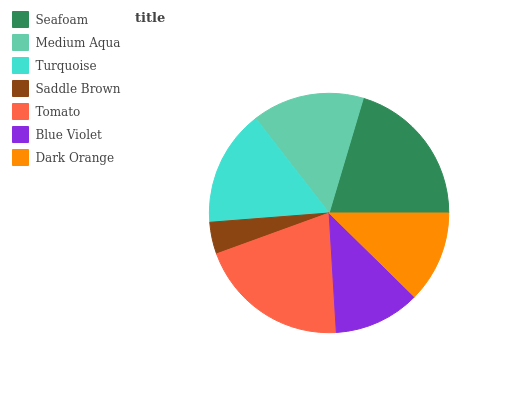Is Saddle Brown the minimum?
Answer yes or no. Yes. Is Tomato the maximum?
Answer yes or no. Yes. Is Medium Aqua the minimum?
Answer yes or no. No. Is Medium Aqua the maximum?
Answer yes or no. No. Is Seafoam greater than Medium Aqua?
Answer yes or no. Yes. Is Medium Aqua less than Seafoam?
Answer yes or no. Yes. Is Medium Aqua greater than Seafoam?
Answer yes or no. No. Is Seafoam less than Medium Aqua?
Answer yes or no. No. Is Medium Aqua the high median?
Answer yes or no. Yes. Is Medium Aqua the low median?
Answer yes or no. Yes. Is Tomato the high median?
Answer yes or no. No. Is Saddle Brown the low median?
Answer yes or no. No. 